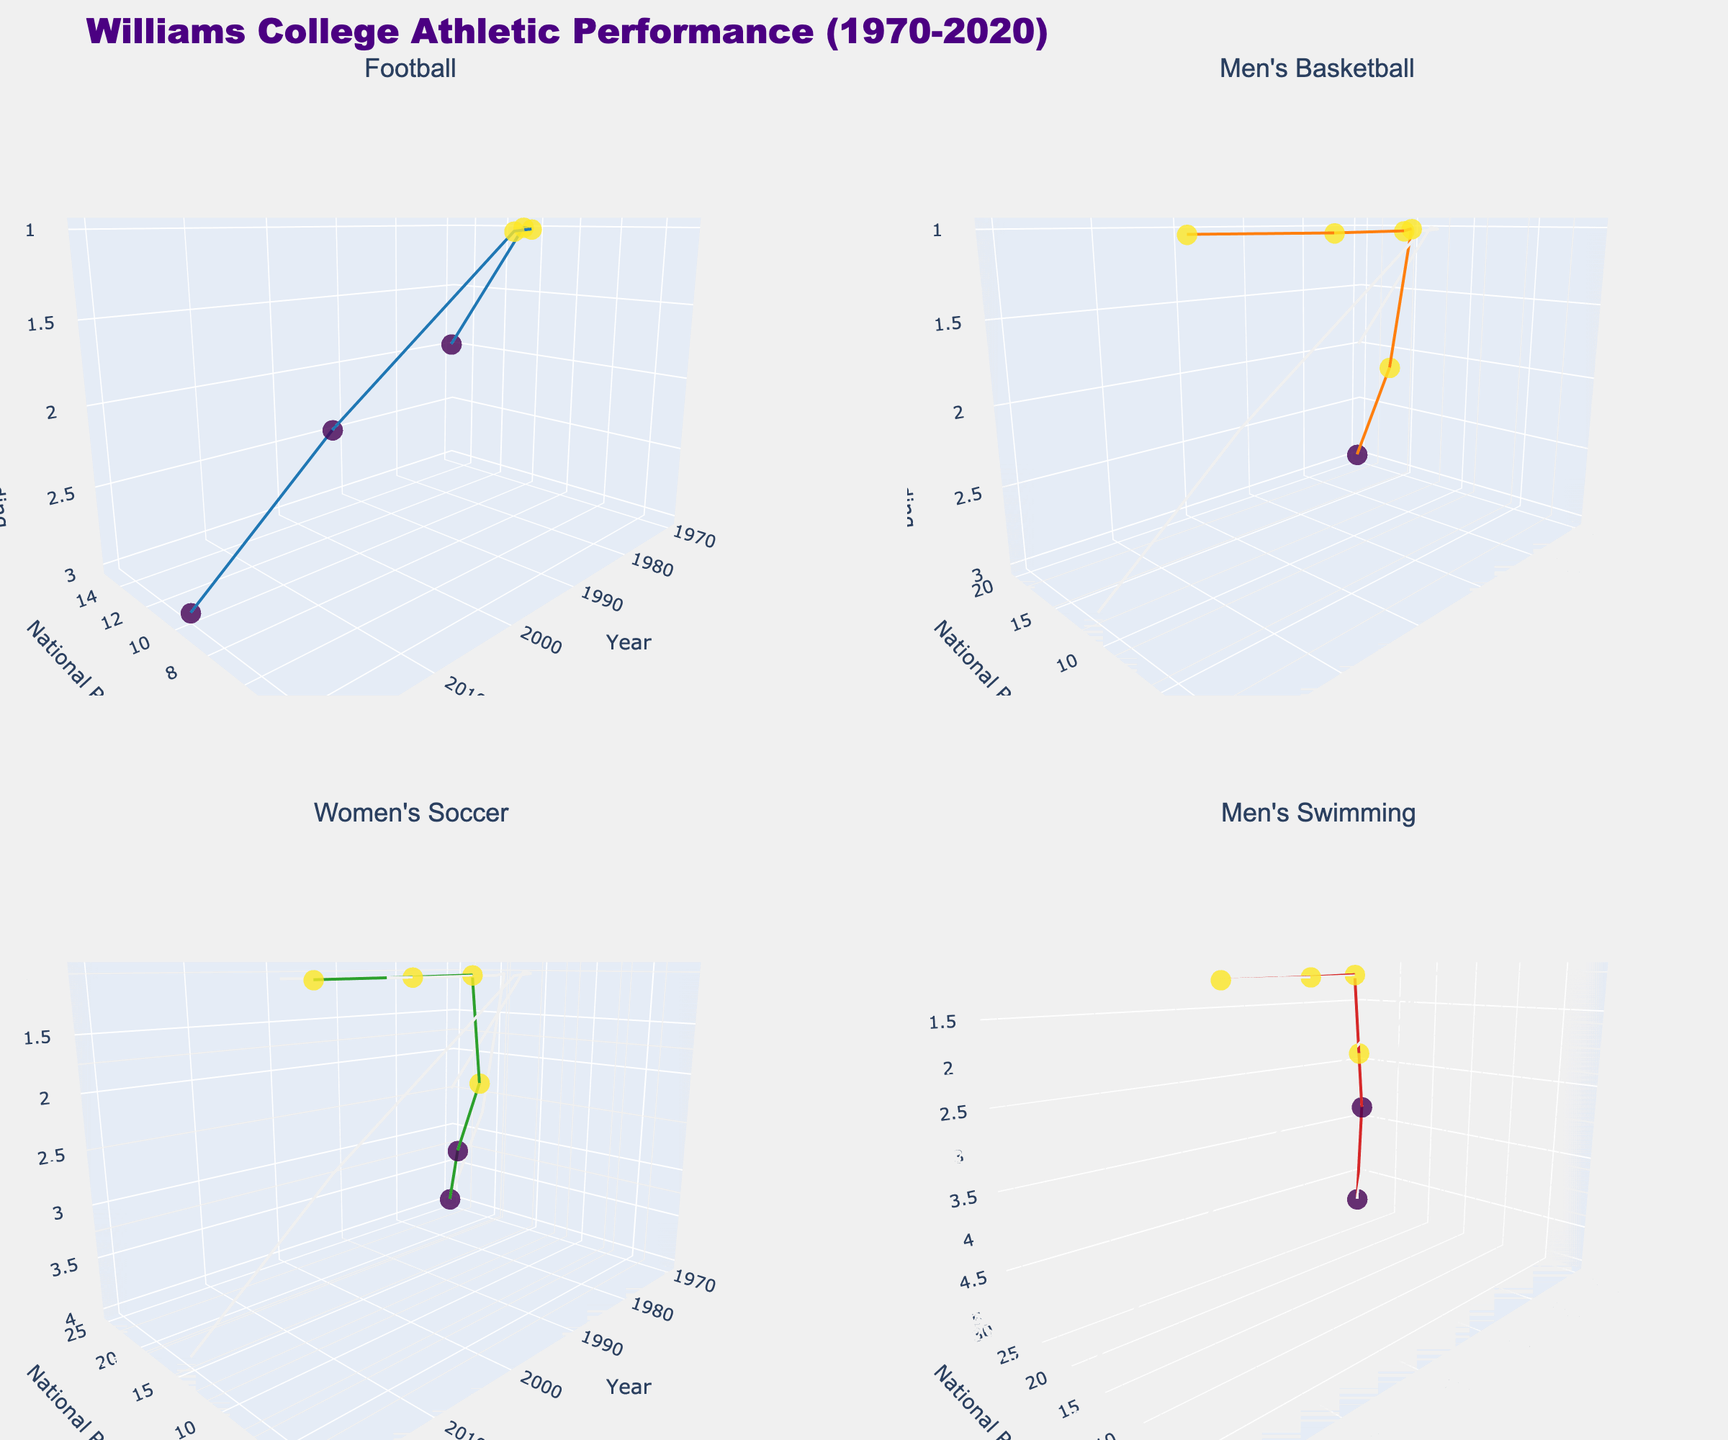What is the overall title of the figure? The overall title is located at the top of the figure. It provides a summary of what the figure represents.
Answer: Williams College Athletic Performance (1970-2020) How many subplots are displayed in the figure? You can count the number of independent scenes, each with a separate title and axes. There are four such plots.
Answer: 4 Which sport showed the highest improvement in national ranking from 1970 to 2020? Comparing the "National Ranking" values for each sport from 1970 to 2020, we observe the changes. The sport that improved from a starting rank to the best ending rank shows the highest improvement.
Answer: Men's Swimming What was the national ranking of the Men's Basketball team in 2010? Look at the subplot for Men's Basketball and locate the data point for the year 2010 on the x-axis. The corresponding value on the y-axis is the national ranking.
Answer: 1 Which sport had the most consistent conference standing over the years? Assess the variability in the "Conference Standing" data points for each sport. The sport with the least variation in its vertical position along the z-axis exhibits consistency.
Answer: Men's Basketball Did the Women's Soccer team win any NESCAC titles between 1970 and 2020? Check the subplot for Women’s Soccer and observe the marker colors or directly the data points to identify if the "NESCAC Titles" count is greater than zero in any of the years.
Answer: Yes Between Men's Basketball and Football, which sport had a better national ranking overall in 2000? In the respective subplots for Men's Basketball and Football, identify the data points for the year 2000 and compare their positions on the y-axis.
Answer: Men's Basketball In 1980, which sport had the highest national ranking? Look at the subplots for each sport and locate the 1980 data points on the x-axis. Compare the y-axis values to determine the highest ranking.
Answer: Football How many NESCAC titles did the Men's Swimming team win by 2020? Locate the subplot for Men's Swimming and check the changing colors or the tooltip on the markers which denote the number of NESCAC titles. Observe the highest value in 2020.
Answer: 1 Comparing the year 1970 and 2020, which sport showed the greatest decline in national ranking? Identify and compare the national ranking values for all sports between 1970 and 2020 and determine which sport had an increase in value (indicating a decline in ranking).
Answer: Football 